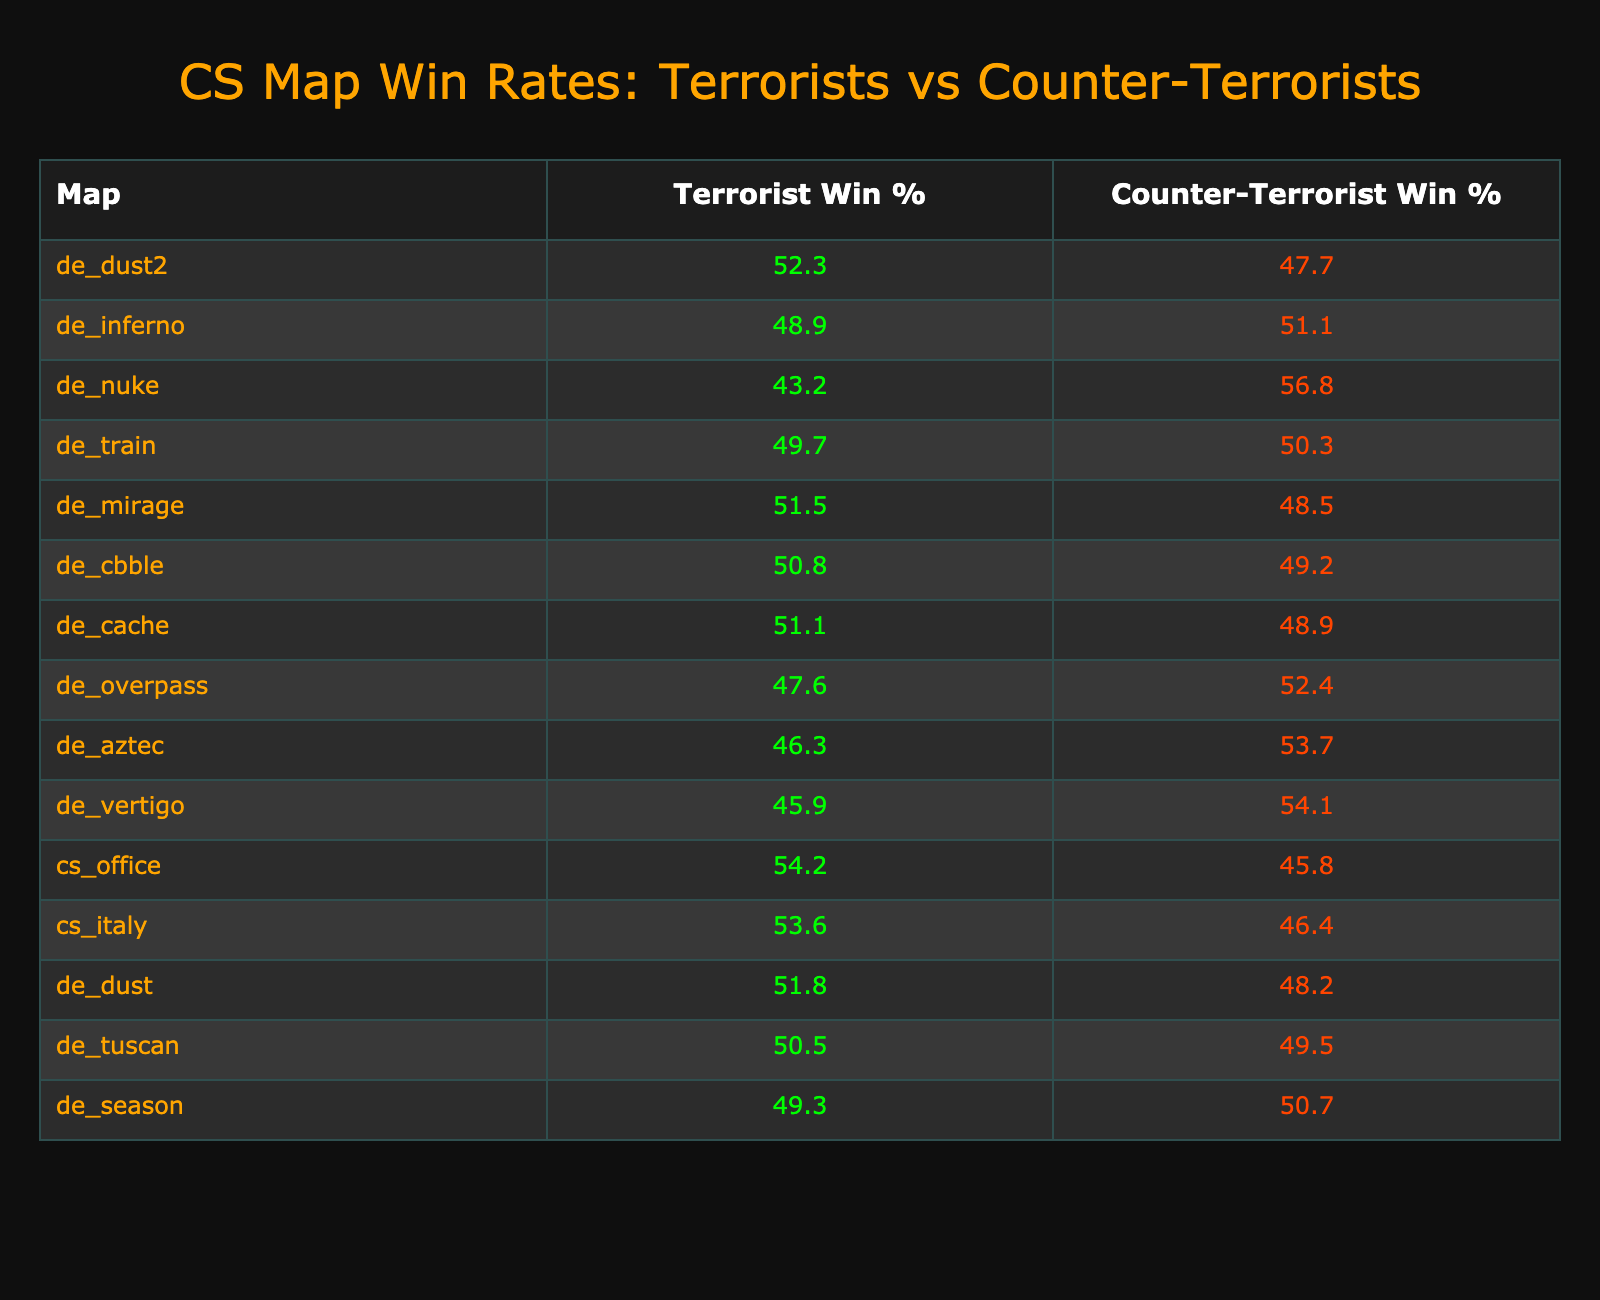What is the Terrorist win percentage on de_dust2? The table lists de_dust2 with a Terrorist win percentage of 52.3%.
Answer: 52.3% Which map has the highest Counter-Terrorist win percentage? The map with the highest Counter-Terrorist win percentage is de_nuke at 56.8%.
Answer: de_nuke What is the difference in win percentages between Terrorists and Counter-Terrorists on de_mirage? For de_mirage, the Terrorist win percentage is 51.5% and the Counter-Terrorist win percentage is 48.5%. The difference is 51.5% - 48.5% = 3%.
Answer: 3% Do Terrorists have a higher win percentage than Counter-Terrorists on de_cache? The table shows that Terrorists have a win percentage of 51.1% and Counter-Terrorists have 48.9% on de_cache, indicating Terrorists do have a higher win percentage.
Answer: Yes Which maps show a win percentage for Terrorists above 50%? The maps with Terrorist win percentages above 50% are de_dust2 (52.3%), de_mirage (51.5%), de_cbble (50.8%), de_cache (51.1%), and cs_office (54.2%).
Answer: 5 maps If you were to average the Terrorist win percentages of de_inferno and de_overpass, what would it be? The Terrorist win percentages are 48.9% for de_inferno and 47.6% for de_overpass. The average is (48.9 + 47.6) / 2 = 48.25%.
Answer: 48.25% Is there any map where the Counter-Terrorist win percentage is exactly 50%? The only map where the Counter-Terrorist win percentage is exactly 50% is de_train.
Answer: Yes What is the combined win percentage for Counter-Terrorists across all maps in the table? To find this, add up all Counter-Terrorist win percentages (47.7 + 51.1 + 56.8 + 50.3 + 48.5 + 49.2 + 48.9 + 52.4 + 53.7 + 54.1 + 45.8 + 46.4 + 48.2 + 49.5 + 50.7) = 754.2. Then divide by the number of maps (15), giving an average of 50.28%.
Answer: 50.28% Which map's results indicate the most balanced competition between the two teams? The map with the closest win percentages is de_train, where Counter-Terrorists have 50.3% and Terrorists have 49.7%, showing a difference of only 0.6%.
Answer: de_train Which team's performance is better overall, based on the win percentages listed in this data? To determine the overall performance, count the maps where Terrorists have a higher percentage (5 maps) and where Counter-Terrorists do (6 maps). Since one team has more higher percentages, Counter-Terrorists perform better overall.
Answer: Counter-Terrorists 